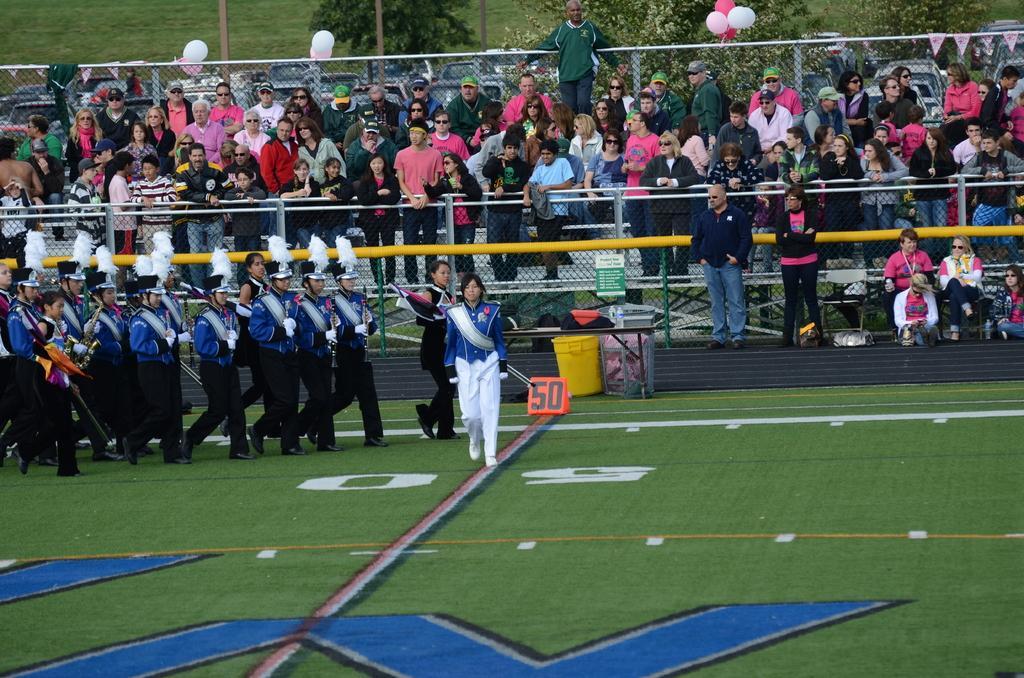How would you summarize this image in a sentence or two? In this picture we can see the group of person wearing the same dress and holding flute and doing march on the ground. In the background we can see another group of persons who are standing near to the fencing and pipes. On the right we can see another group of persons were sitting on the chair. At the top we can see the trees and grass. On the fencing we can see the white and pink color balloons. At the bottom we can see the grass and ground. 